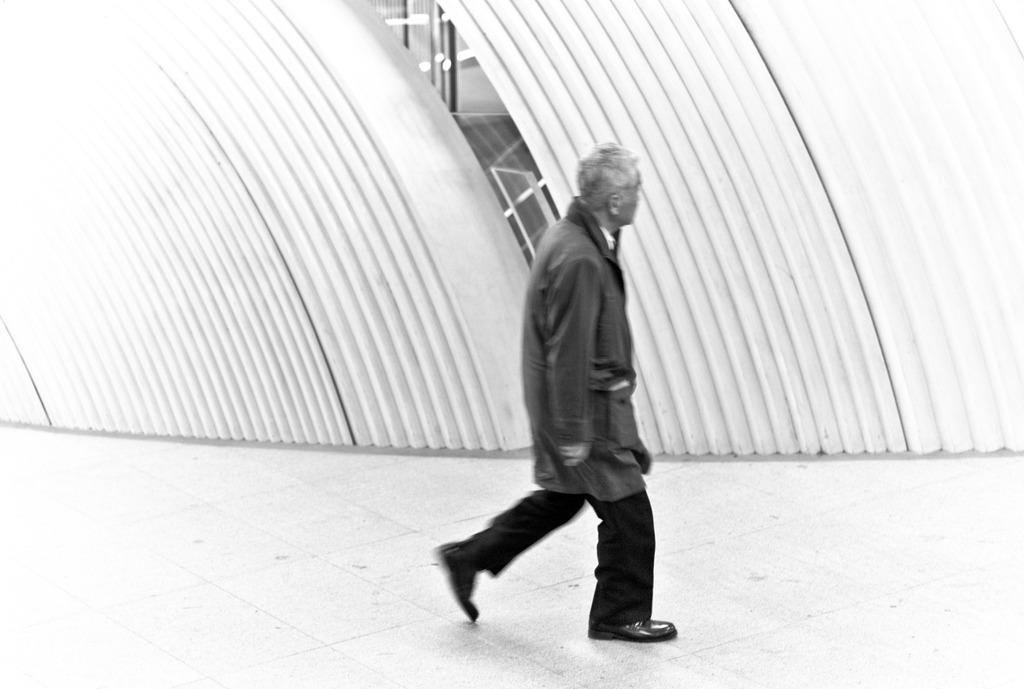Who is present in the image? There is a man in the image. What is the man doing in the image? The man is walking in the image. What type of clothing is the man wearing? The man is wearing a coat and shoes in the image. What can be seen in the background of the image? There is a wall in the background of the image. Reasoning: Let's think step by step by step in order to produce the conversation. We start by identifying the main subject in the image, which is the man. Then, we describe his actions and clothing, as well as the background of the image. Each question is designed to elicit a specific detail about the image that is known from the provided facts. Absurd Question/Answer: What type of bait is the man using to catch fish in the image? There is no indication of fishing or bait in the image; the man is simply walking. What type of yam is the man holding in the image? There is no yam present in the image; the man is wearing a coat and shoes and walking. What type of copy is the man making of the wall in the image? There is no indication of copying or duplicating the wall in the image; the man is simply walking. 